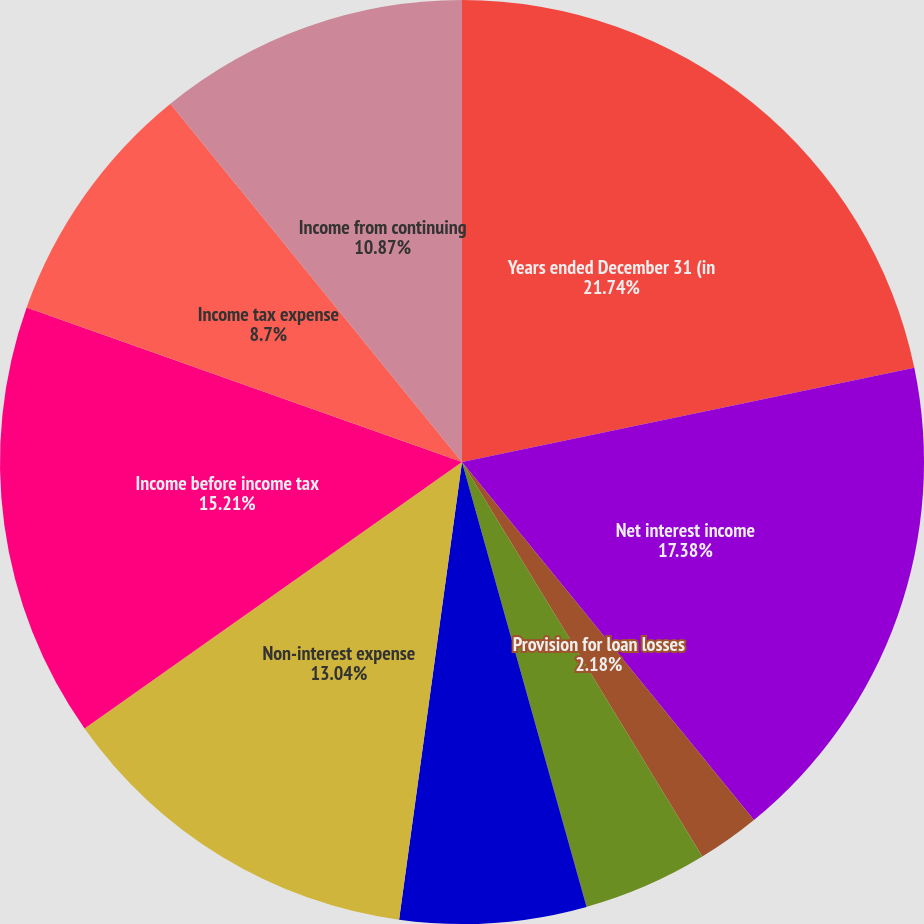Convert chart. <chart><loc_0><loc_0><loc_500><loc_500><pie_chart><fcel>Years ended December 31 (in<fcel>Net interest income<fcel>Provision for loan losses<fcel>Fee-based revenues<fcel>Other non-interest income<fcel>Total non-interest income<fcel>Non-interest expense<fcel>Income before income tax<fcel>Income tax expense<fcel>Income from continuing<nl><fcel>21.73%<fcel>17.38%<fcel>2.18%<fcel>4.35%<fcel>0.01%<fcel>6.52%<fcel>13.04%<fcel>15.21%<fcel>8.7%<fcel>10.87%<nl></chart> 